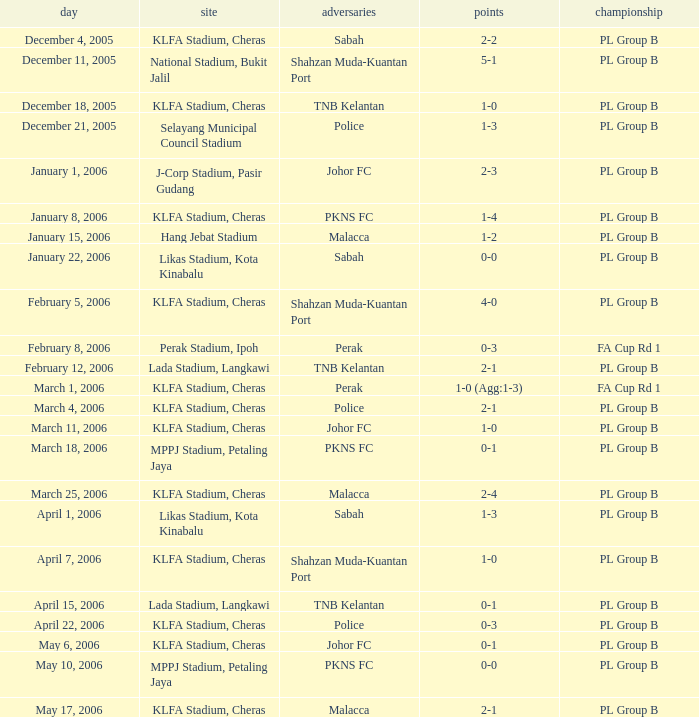Which Competition has a Score of 0-1, and Opponents of pkns fc? PL Group B. 